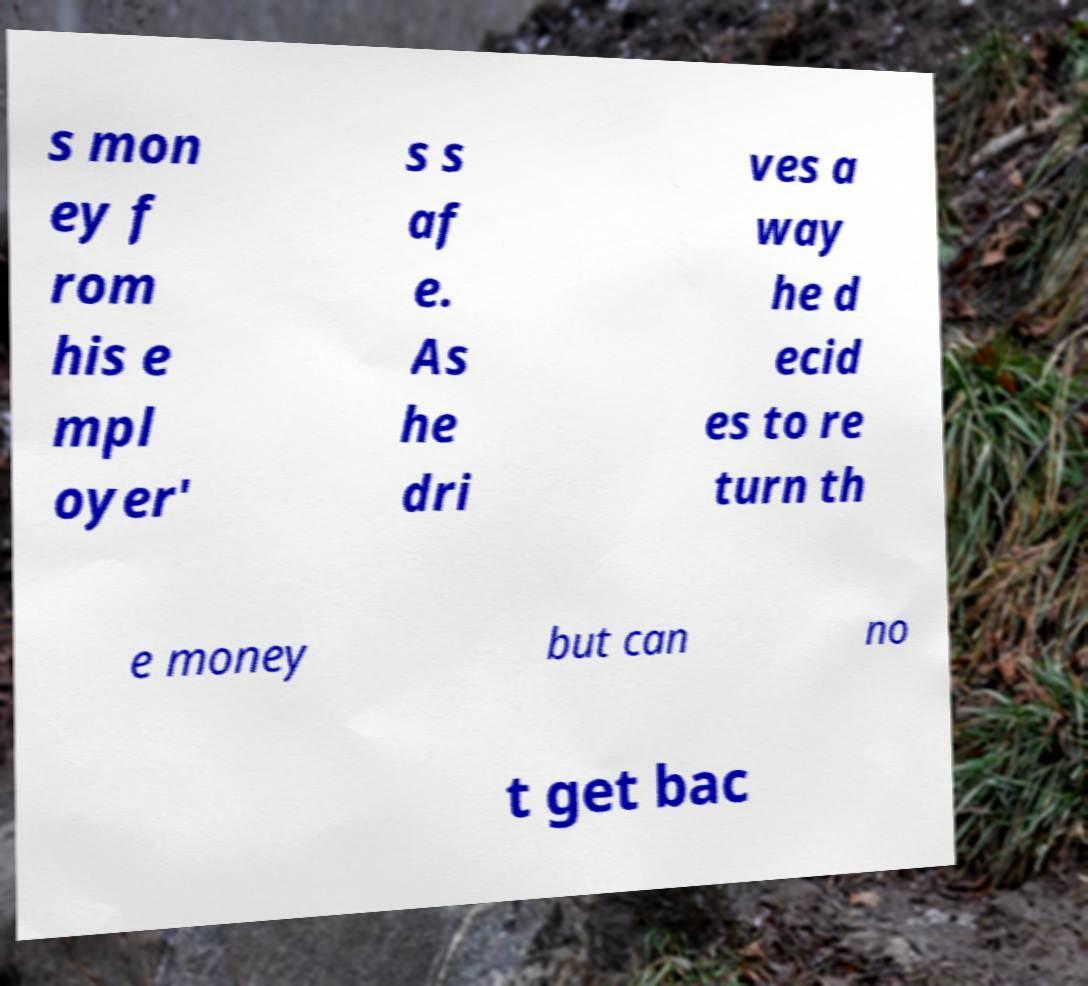I need the written content from this picture converted into text. Can you do that? s mon ey f rom his e mpl oyer' s s af e. As he dri ves a way he d ecid es to re turn th e money but can no t get bac 